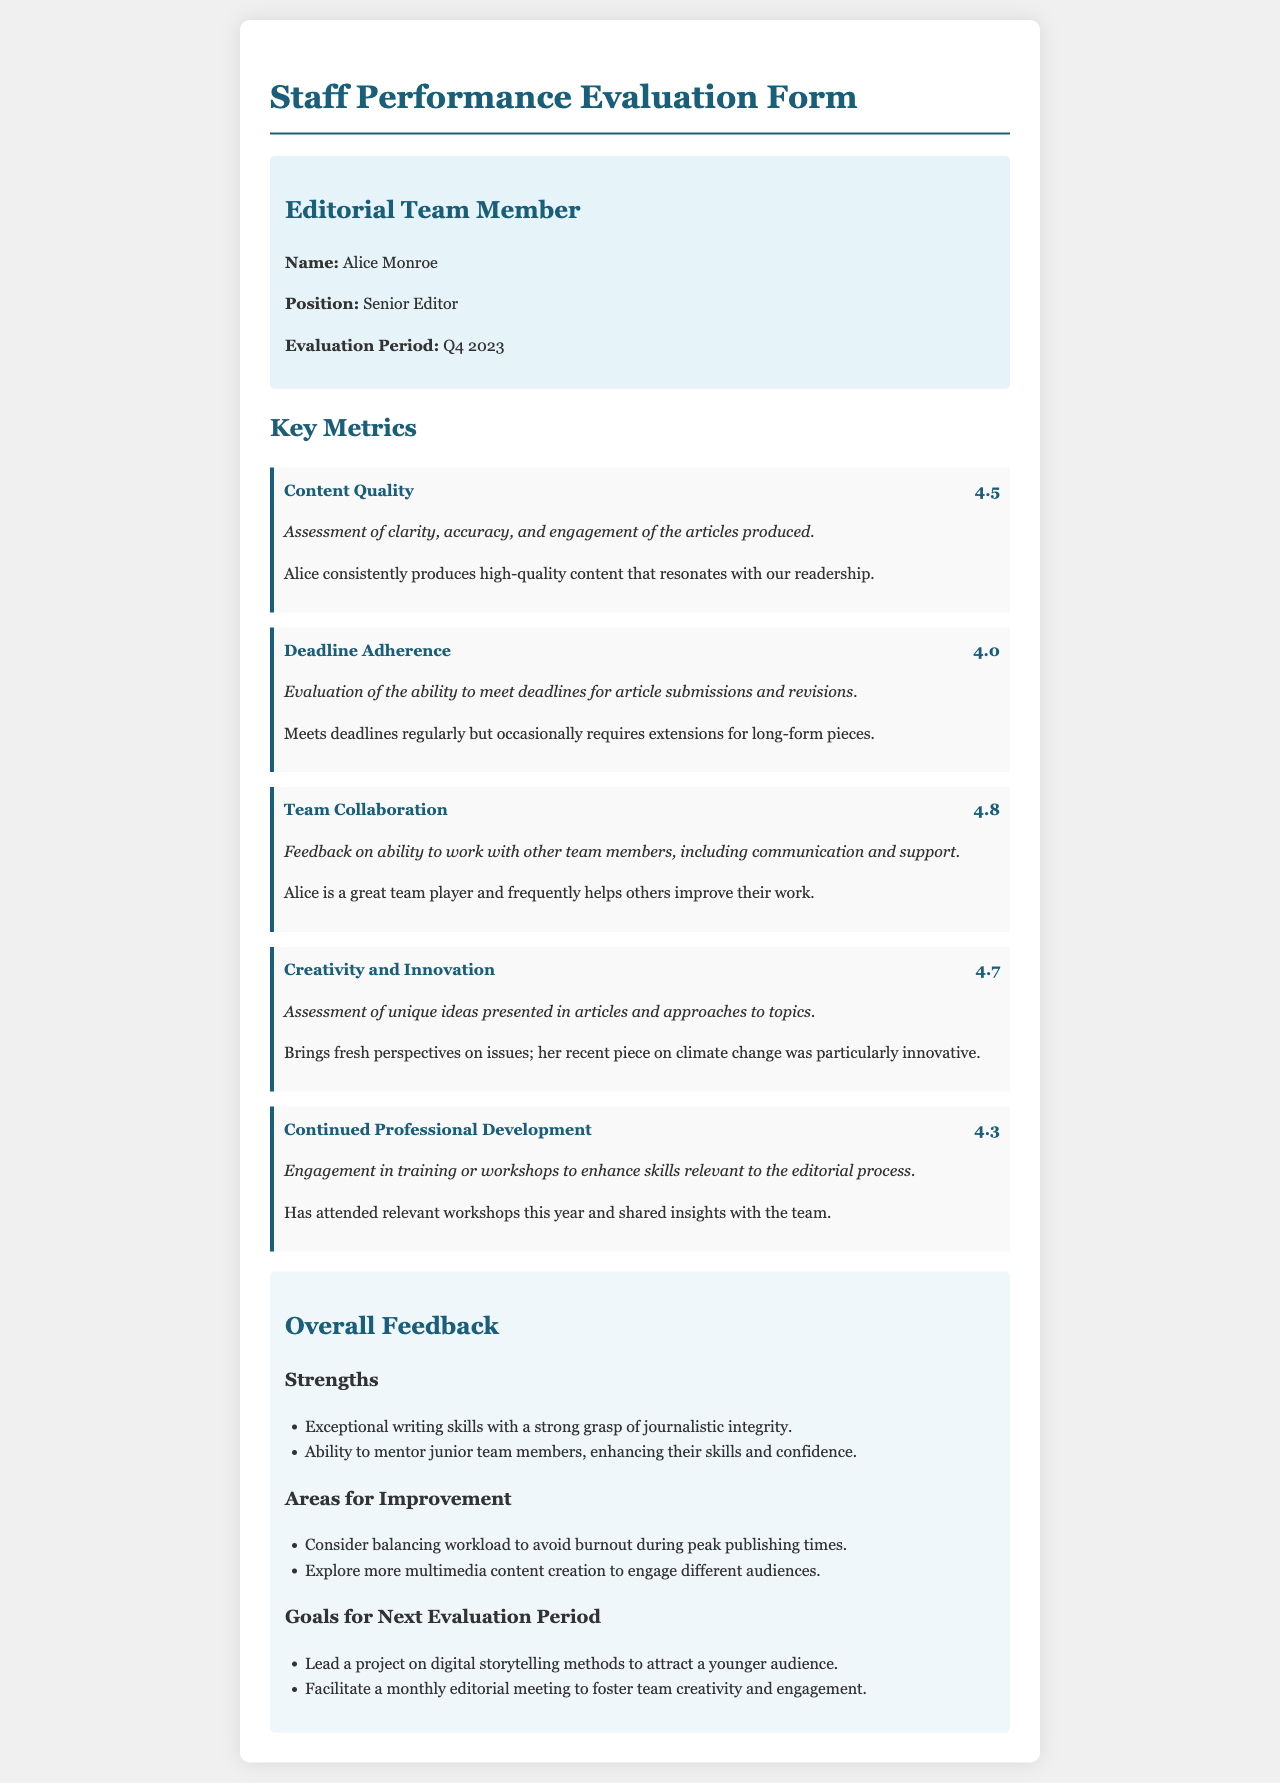What is the name of the staff member evaluated? The document provides the name of the staff member in the editorial team section, which is Alice Monroe.
Answer: Alice Monroe What is the position of Alice Monroe? The position of Alice Monroe is specified in the staff information section of the document as Senior Editor.
Answer: Senior Editor What is the evaluation period mentioned in the document? The evaluation period is noted within the staff information section as Q4 2023.
Answer: Q4 2023 What score did Alice receive for Content Quality? The score for Content Quality is provided in the key metrics section, which states a score of 4.5.
Answer: 4.5 What are Alice's strengths according to the feedback section? Strengths are listed in a bullet point format; two specific strengths are exceptional writing skills and ability to mentor junior team members.
Answer: Exceptional writing skills What is suggested as an area for improvement? The document outlines areas for improvement; one area suggested is to balance workload to avoid burnout.
Answer: Balance workload What is one of the goals for the next evaluation period? Goals for the next evaluation period are mentioned in the feedback section; one goal is to lead a project on digital storytelling methods.
Answer: Lead a project on digital storytelling methods Which metric received the highest score? The metric with the highest score is Team Collaboration, which scored 4.8 according to the evaluation section.
Answer: Team Collaboration What is highlighted in Alice's assessment regarding creativity? The document states she brings fresh perspectives on issues, emphasizing her creativity in reporting.
Answer: Brings fresh perspectives on issues 